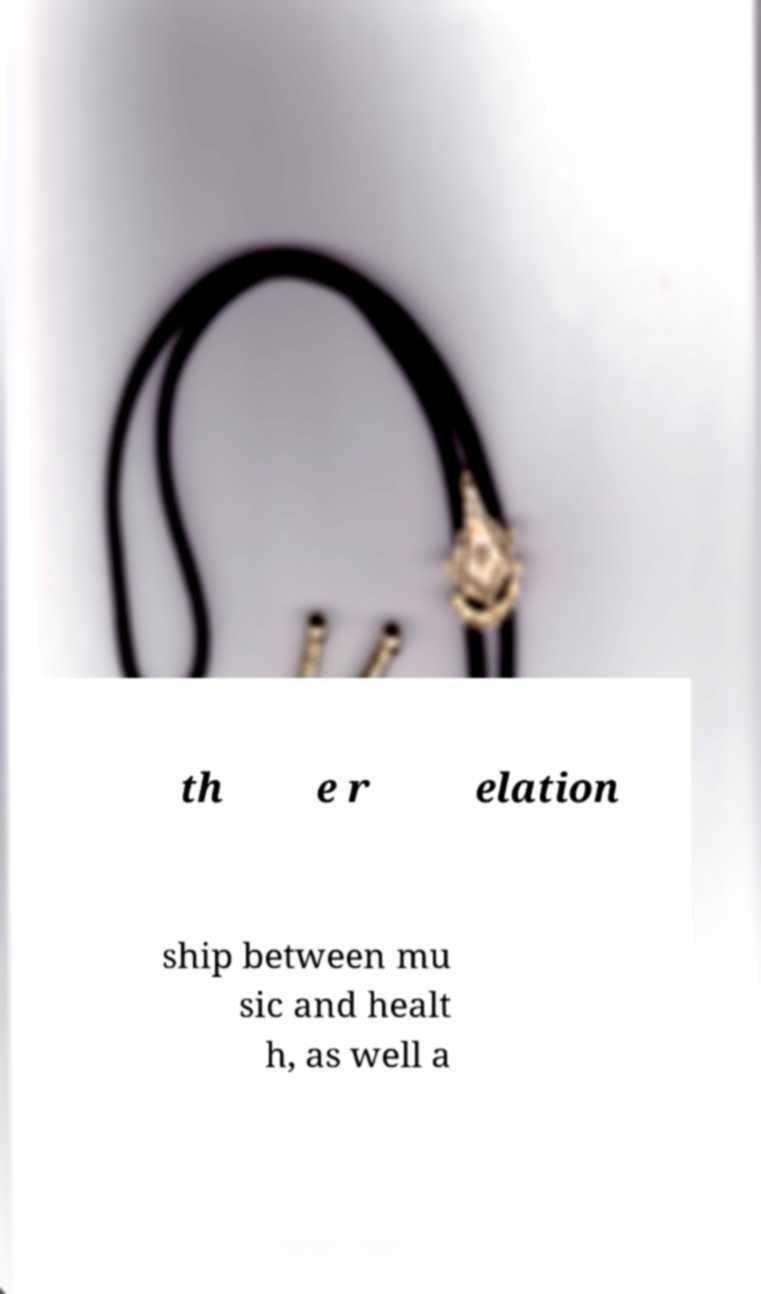What messages or text are displayed in this image? I need them in a readable, typed format. th e r elation ship between mu sic and healt h, as well a 